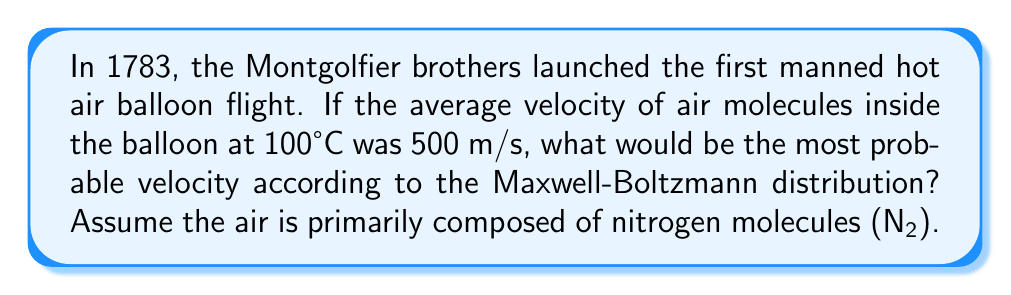Provide a solution to this math problem. To solve this problem, we'll use the Maxwell-Boltzmann distribution and its properties:

1. The Maxwell-Boltzmann distribution gives the probability density of particle velocities in a gas.

2. For this distribution, the relationship between the average velocity ($\bar{v}$) and the most probable velocity ($v_p$) is:

   $$v_p = \sqrt{\frac{2}{3}} \bar{v}$$

3. We are given that the average velocity $\bar{v} = 500$ m/s.

4. Substituting this into the equation:

   $$v_p = \sqrt{\frac{2}{3}} \cdot 500 \text{ m/s}$$

5. Simplifying:

   $$v_p = \sqrt{\frac{2}{3}} \cdot 500 \text{ m/s} = \frac{\sqrt{2}}{3^{1/4}} \cdot 500 \text{ m/s}$$

6. Calculate the final result:

   $$v_p \approx 408.25 \text{ m/s}$$

This result shows that in the early balloon flights, the most probable velocity of air molecules inside the balloon was slightly lower than the average velocity, which is consistent with the Maxwell-Boltzmann distribution's skewed nature.
Answer: $408.25 \text{ m/s}$ 